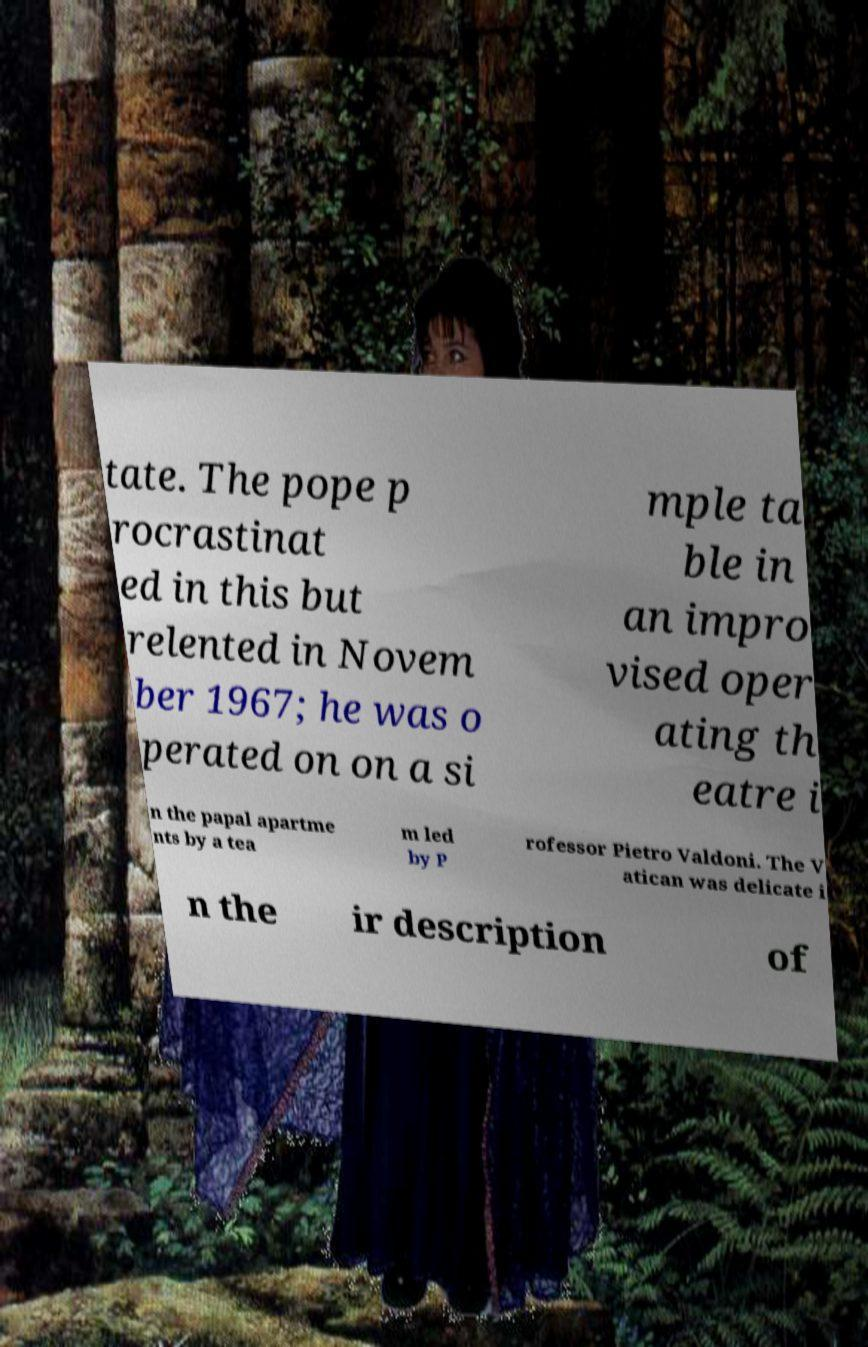There's text embedded in this image that I need extracted. Can you transcribe it verbatim? tate. The pope p rocrastinat ed in this but relented in Novem ber 1967; he was o perated on on a si mple ta ble in an impro vised oper ating th eatre i n the papal apartme nts by a tea m led by P rofessor Pietro Valdoni. The V atican was delicate i n the ir description of 